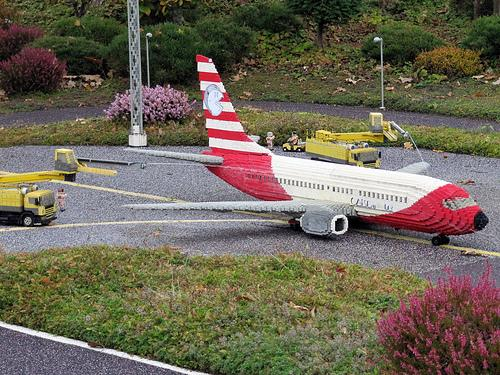Analyze the context of the image in terms of toys, vehicles, and nature. The context suggests a playful and imaginative setup of toy vehicles, including an airplane made of Legos, yellow trucks, and a small jeep, placed on a concrete surface surrounded by a patch of grass and colorful bushes, depicting an interesting combination of toy vehicles and natural elements. Is there any anomaly in the image related to the airplane's size or position? The airplane's size and position over a patch of grass and beside a yellow truck on the concrete surface might be considered an anomaly, as it might not be a typical scene. What emotions or feelings might someone experience while looking at this image? Someone might feel intrigued, amused, or excited due to the presence of Lego airplanes, colorful bushes, and yellow toy trucks in various positions. Identify the different surfaces in the image and the colors associated with them. There are concrete and grass surfaces in the image. The concrete is gray, and the grass is green with plants and flowers of various colors. What sort of scene is depicted in the image, involving toys and nature? The scene depicts a diorama of toy vehicles like airplanes, trucks, and jeeps on a concrete surface accompanied by a patch of grass and bushes filled with colorful flowers. What kind of toy occupies the center of the image, and what is it made of? The center of the image features a red and white airplane toy, and it is made of Legos. Describe the colors and details of the airplane's wings and tail fin in the image. The wings of the airplane are gray and long, and the tail fin is red and white with a graphic design on it. What is the predominant color of the flowers on the bushes in the image? The flowers on the bushes in the image are predominantly purple, violet, pink, and fuchsia. What details of the airplane are visible in the image? Visible details of the airplane include the engine, windows, wings, tail wing, front wheel, nose, and red and white stripes on the tail fin. 